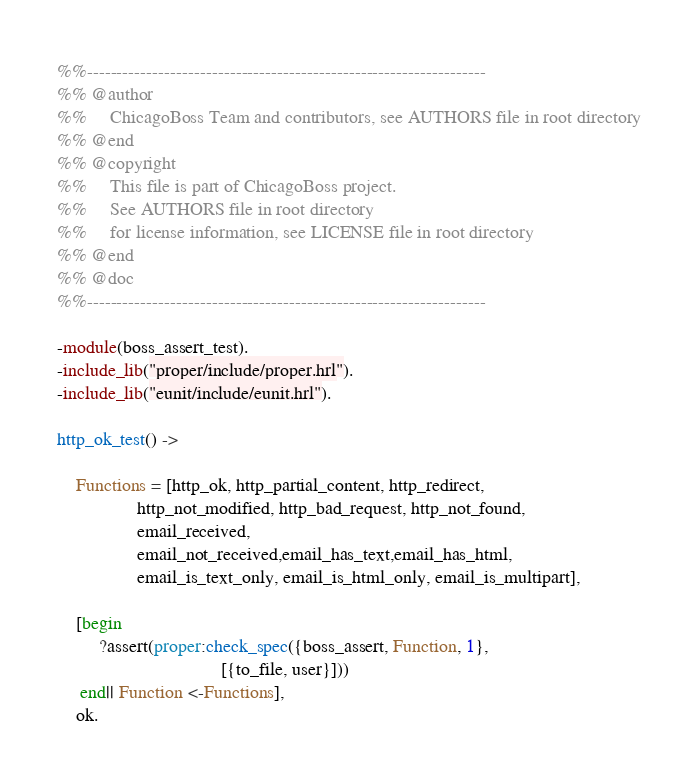<code> <loc_0><loc_0><loc_500><loc_500><_Erlang_>%%-------------------------------------------------------------------
%% @author
%%     ChicagoBoss Team and contributors, see AUTHORS file in root directory
%% @end
%% @copyright
%%     This file is part of ChicagoBoss project.
%%     See AUTHORS file in root directory
%%     for license information, see LICENSE file in root directory
%% @end
%% @doc
%%-------------------------------------------------------------------

-module(boss_assert_test).
-include_lib("proper/include/proper.hrl").
-include_lib("eunit/include/eunit.hrl").

http_ok_test() ->

    Functions = [http_ok, http_partial_content, http_redirect,
                 http_not_modified, http_bad_request, http_not_found,
                 email_received,
                 email_not_received,email_has_text,email_has_html,
                 email_is_text_only, email_is_html_only, email_is_multipart],

    [begin
         ?assert(proper:check_spec({boss_assert, Function, 1},
                                   [{to_file, user}]))
     end|| Function <-Functions],
    ok.
</code> 